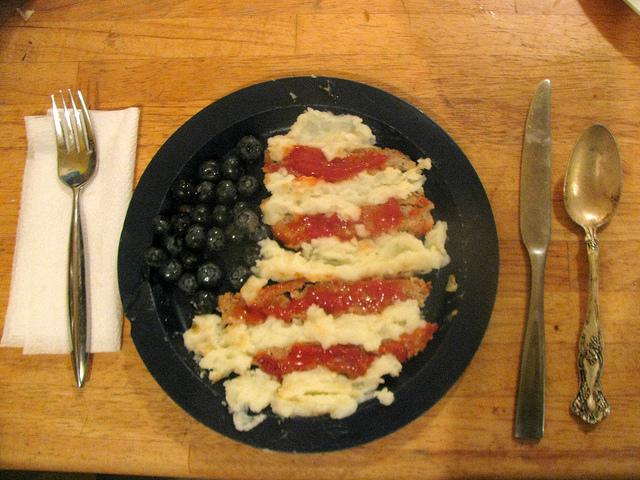What does the food look like?
Be succinct. American flag. Is the spoon real silver?
Quick response, please. Yes. What utensil is on the napkin?
Quick response, please. Fork. 